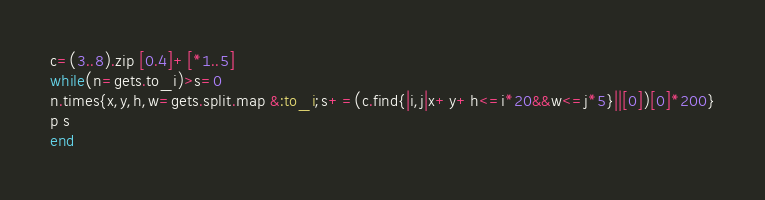Convert code to text. <code><loc_0><loc_0><loc_500><loc_500><_Ruby_>c=(3..8).zip [0.4]+[*1..5]
while(n=gets.to_i)>s=0
n.times{x,y,h,w=gets.split.map &:to_i;s+=(c.find{|i,j|x+y+h<=i*20&&w<=j*5}||[0])[0]*200}
p s
end</code> 